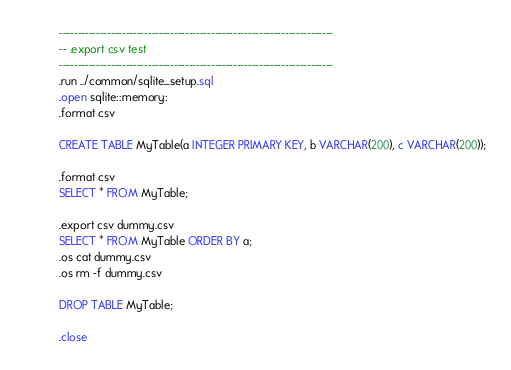Convert code to text. <code><loc_0><loc_0><loc_500><loc_500><_SQL_>--------------------------------------------------------------------------
-- .export csv test
--------------------------------------------------------------------------
.run ../common/sqlite_setup.sql
.open sqlite::memory:
.format csv

CREATE TABLE MyTable(a INTEGER PRIMARY KEY, b VARCHAR(200), c VARCHAR(200));

.format csv
SELECT * FROM MyTable;

.export csv dummy.csv
SELECT * FROM MyTable ORDER BY a;
.os cat dummy.csv
.os rm -f dummy.csv

DROP TABLE MyTable;

.close

</code> 